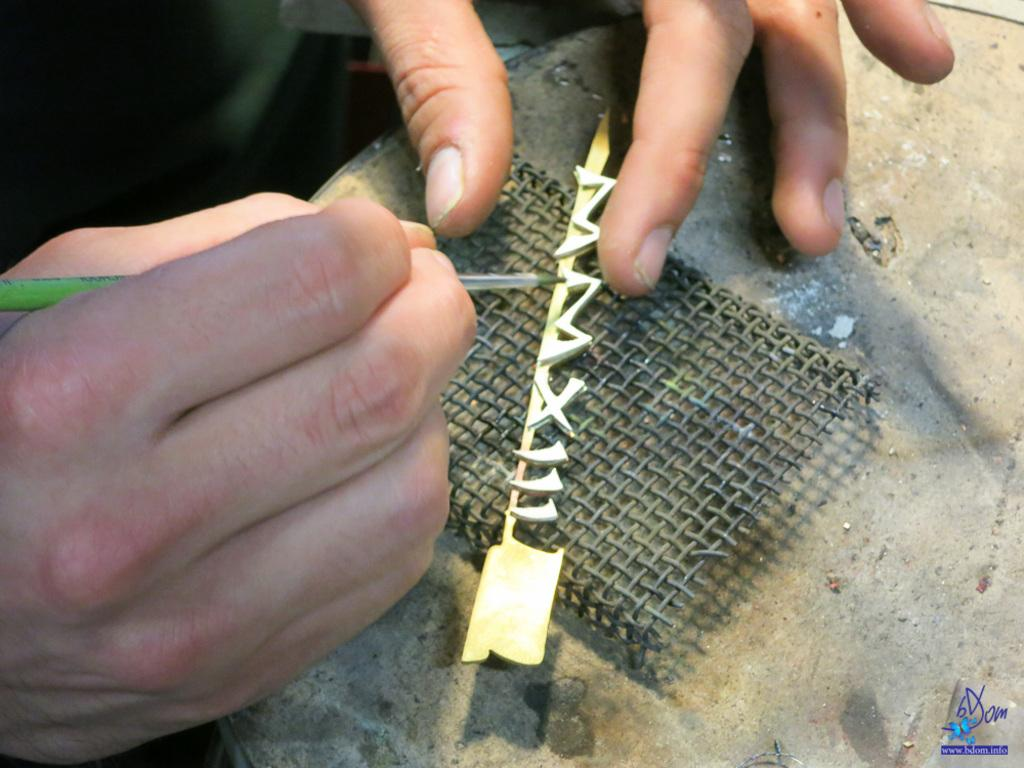What type of metal can be seen in the image? There is iron metal on a rock in the image. Can you describe the person in the image? There is a person in the image. What is the person holding in the image? The person is holding a pen. What color is the pen? The pen is green in color. Can you tell me what the person is watching in the image? There is no reference to the person watching anything in the image. Is there a rat present in the image? There is no mention of a rat in the image. 